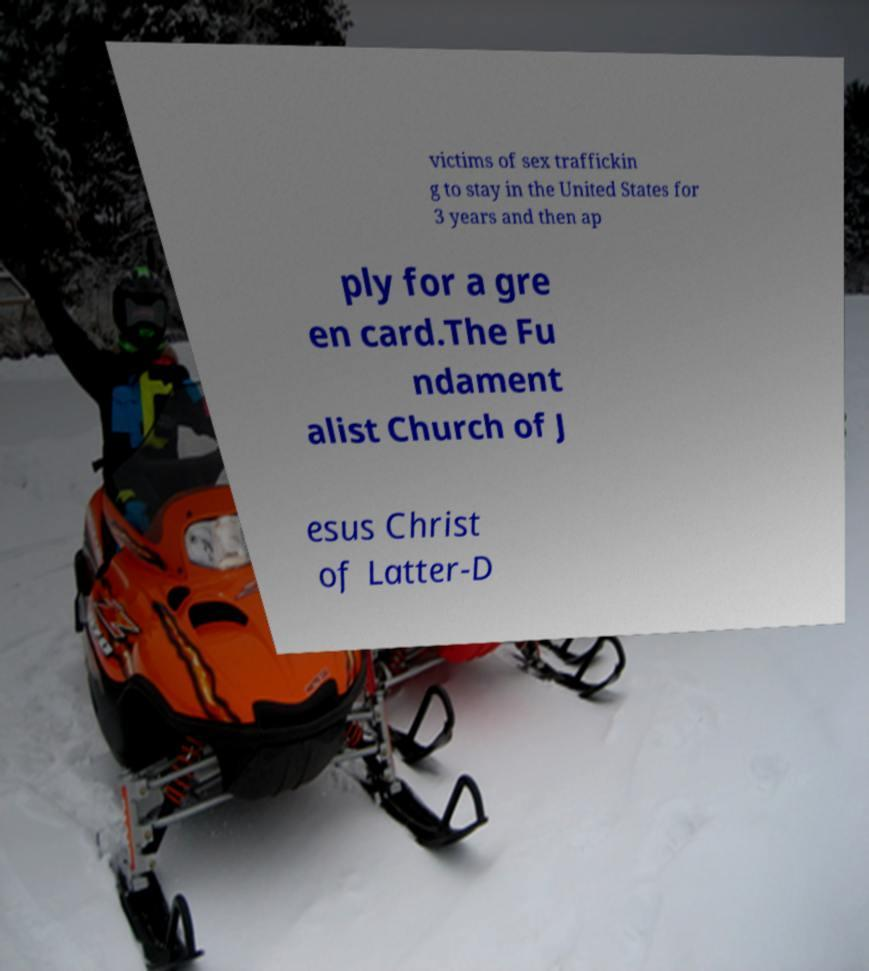What messages or text are displayed in this image? I need them in a readable, typed format. victims of sex traffickin g to stay in the United States for 3 years and then ap ply for a gre en card.The Fu ndament alist Church of J esus Christ of Latter-D 